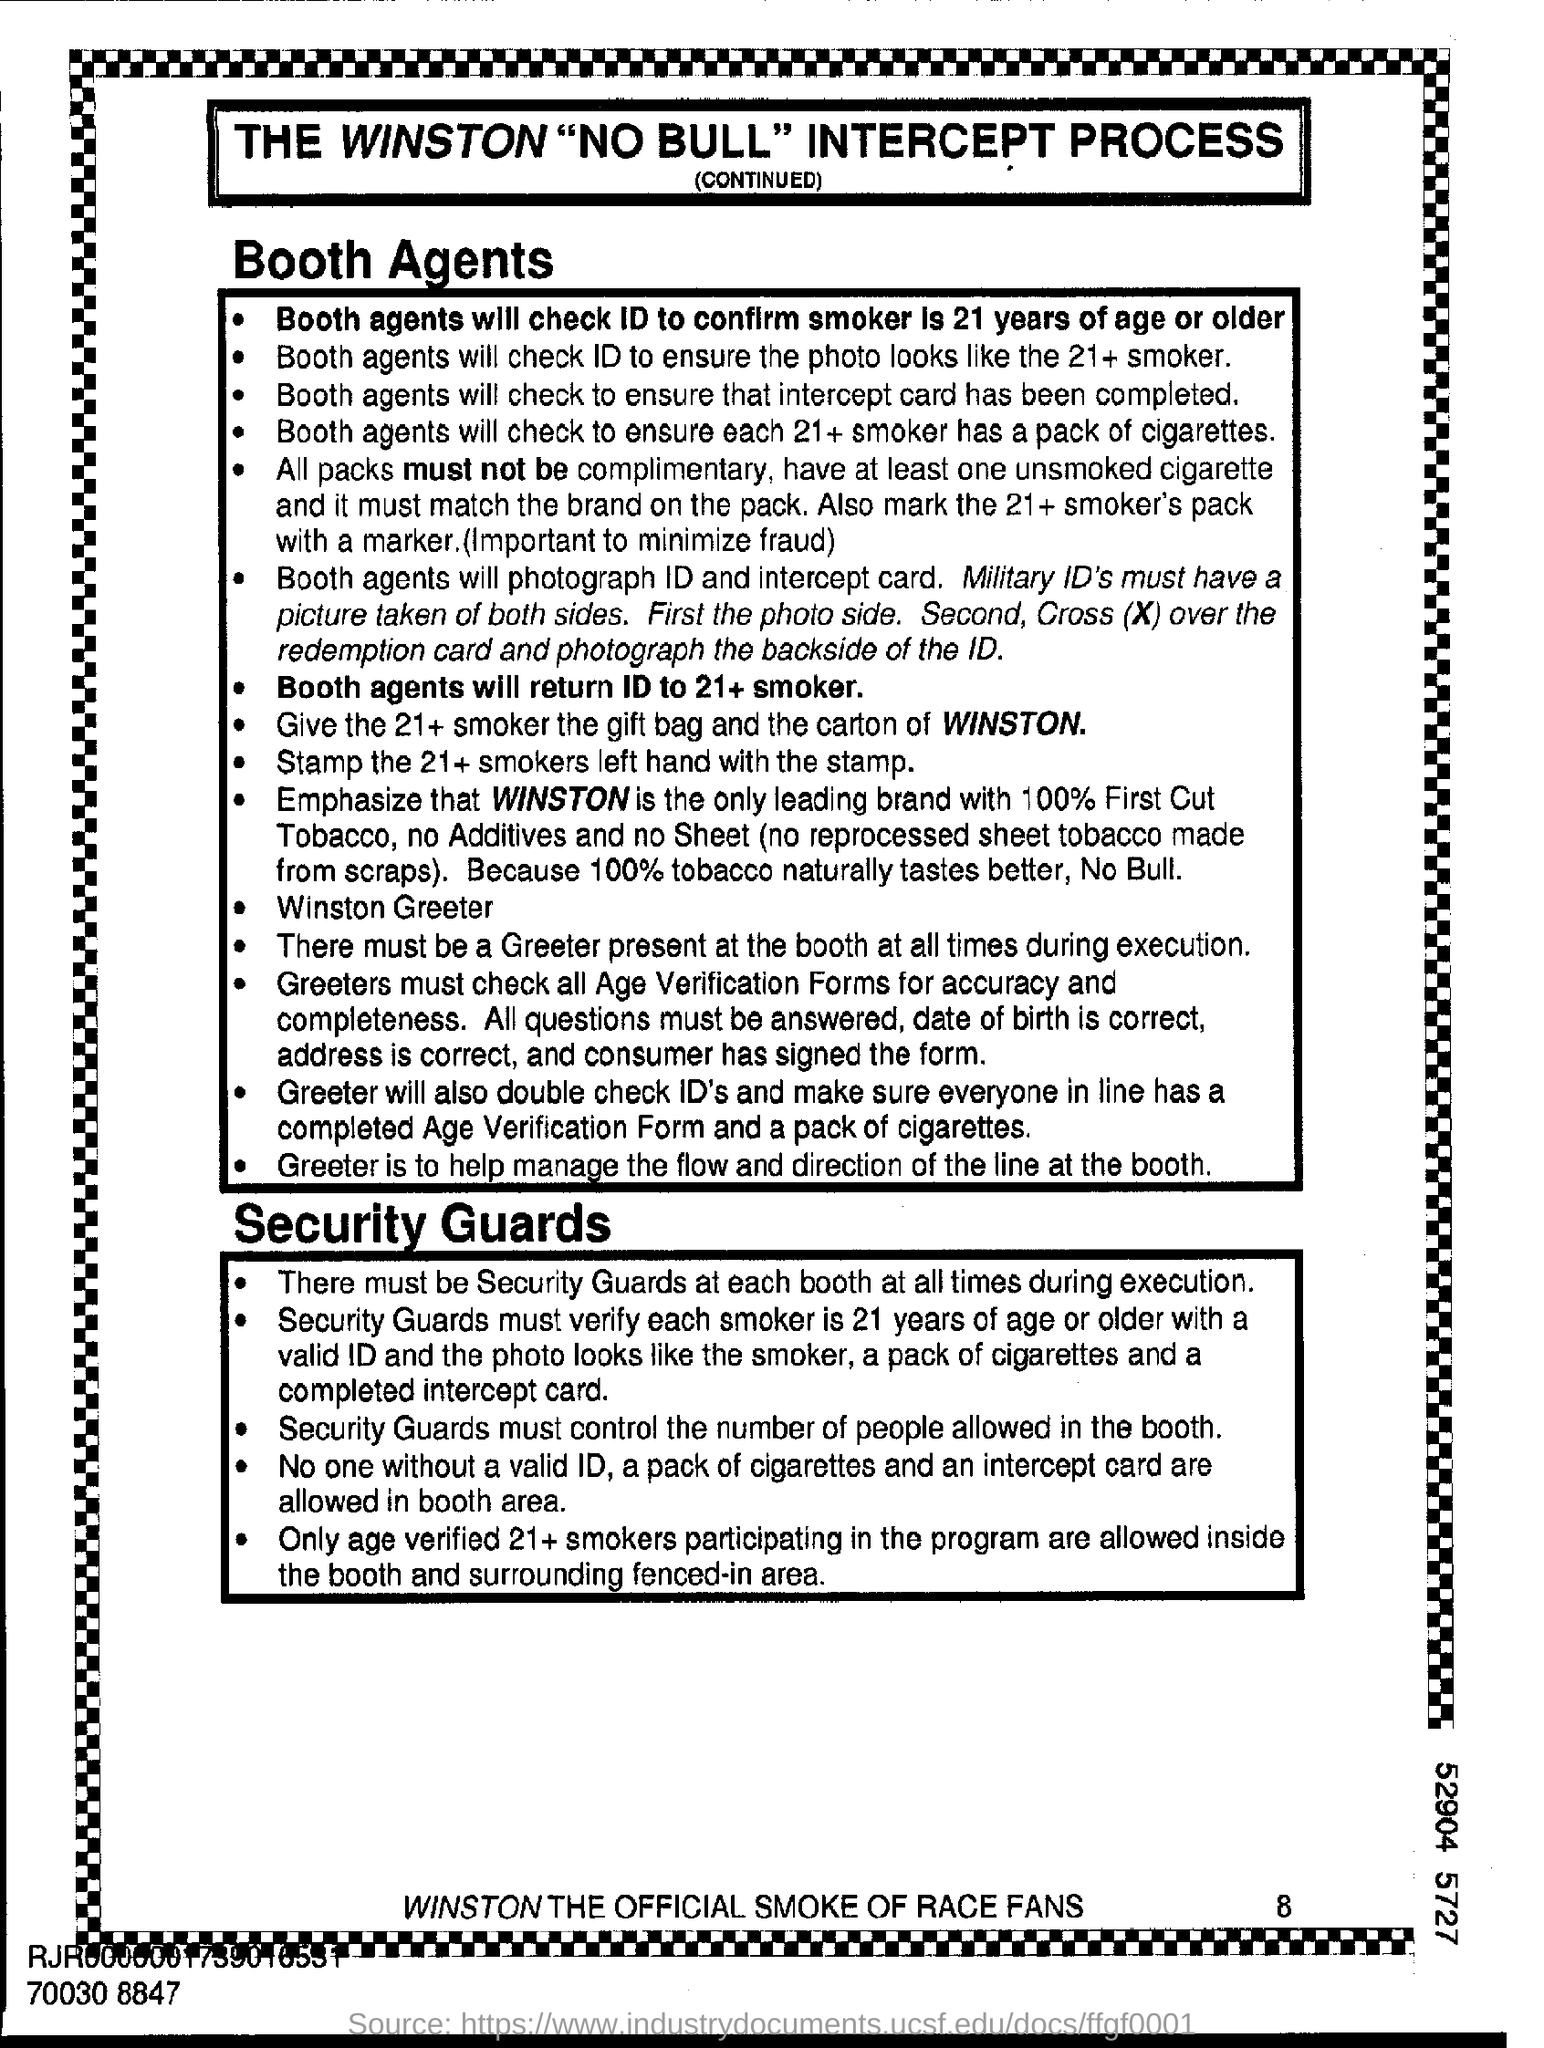What process is mentioned in the flyer?
Provide a succinct answer. The Winston "NO BULL" intercept process. How old should the smoker be?
Make the answer very short. 21 years of age. What card will the booth agents check to ensure it is complete?
Offer a terse response. Intercept card. Should all packs be complementary?
Your answer should be compact. All packs must not  be. Which ID's must have a picture taken of both sides?
Offer a terse response. Military ID's. Which hand of the 21+ smokers should be stamped with the stamp?
Keep it short and to the point. Left hand. Who must be present at the booths at all times during execution?
Your response must be concise. Greeter. Who must control the number of people allowed in the booth?
Ensure brevity in your answer.  Security guards. Which brand is the official smoke of race fans?
Offer a terse response. Winston. 